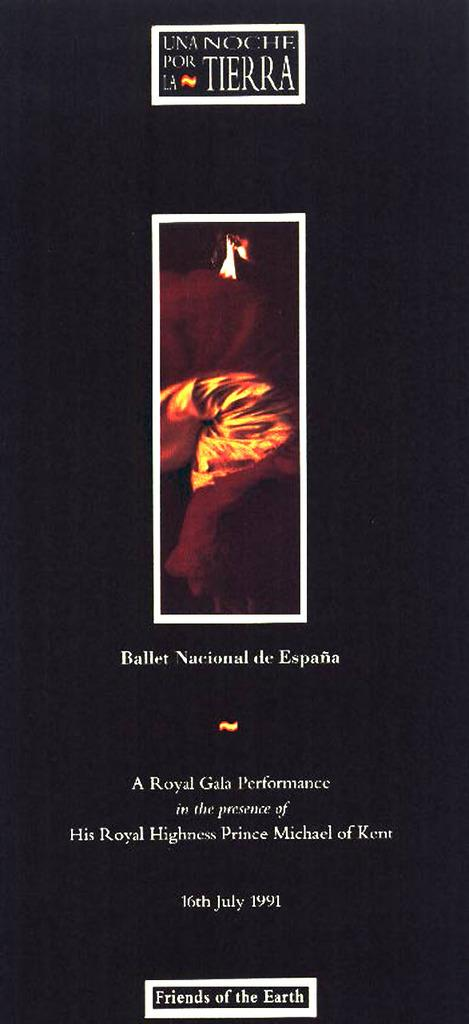What type of visual is the image? The image is a poster. What elements are present on the poster? The poster contains text and an image. What color is the vein visible on the edge of the poster? There is no vein visible on the edge of the poster, as it is a flat, printed image. 